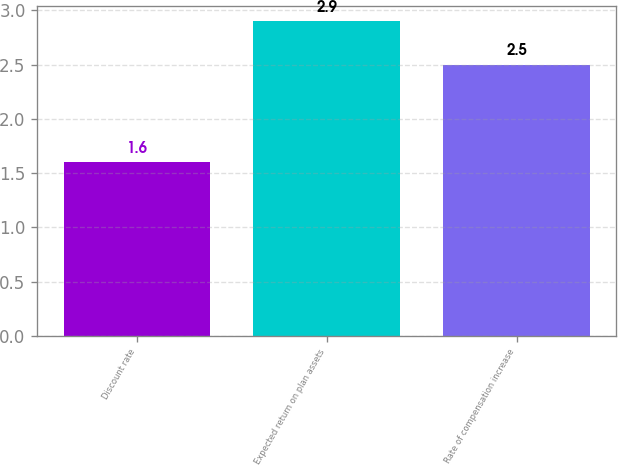Convert chart. <chart><loc_0><loc_0><loc_500><loc_500><bar_chart><fcel>Discount rate<fcel>Expected return on plan assets<fcel>Rate of compensation increase<nl><fcel>1.6<fcel>2.9<fcel>2.5<nl></chart> 